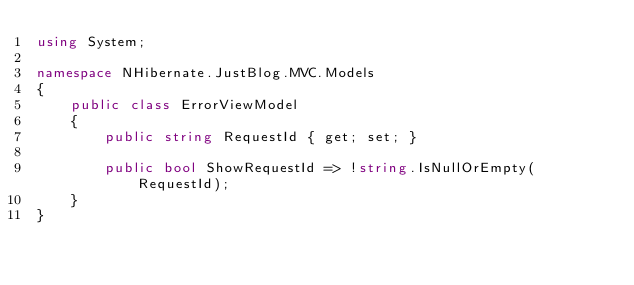Convert code to text. <code><loc_0><loc_0><loc_500><loc_500><_C#_>using System;

namespace NHibernate.JustBlog.MVC.Models
{
    public class ErrorViewModel
    {
        public string RequestId { get; set; }

        public bool ShowRequestId => !string.IsNullOrEmpty(RequestId);
    }
}
</code> 